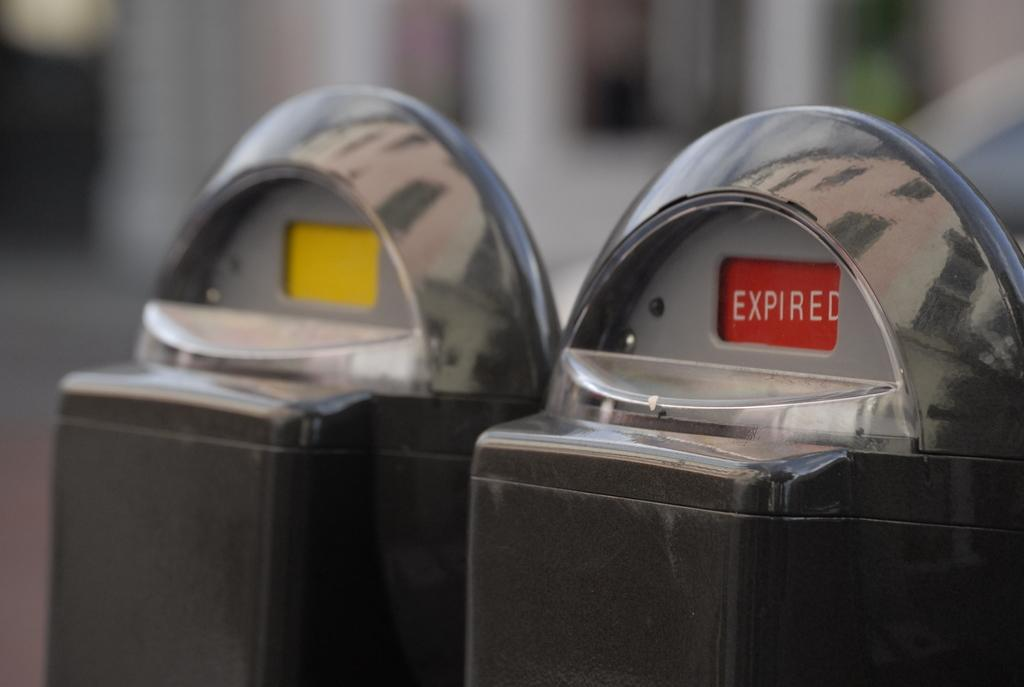Provide a one-sentence caption for the provided image. Two parking meters on a street with showing expired in red and the other showing yellow in the window. 